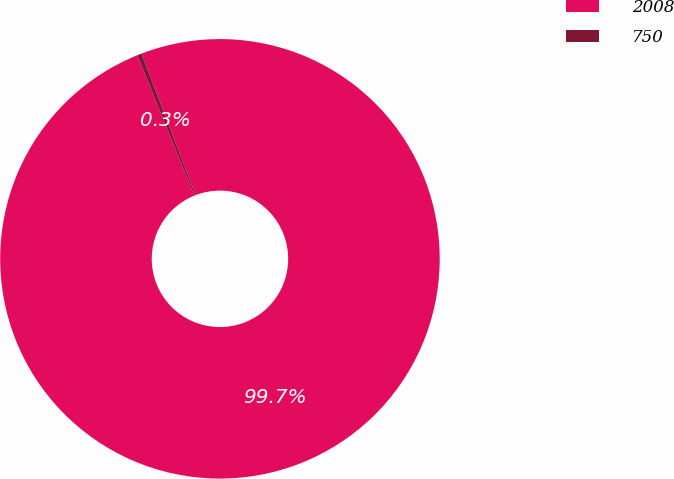<chart> <loc_0><loc_0><loc_500><loc_500><pie_chart><fcel>2008<fcel>750<nl><fcel>99.68%<fcel>0.32%<nl></chart> 